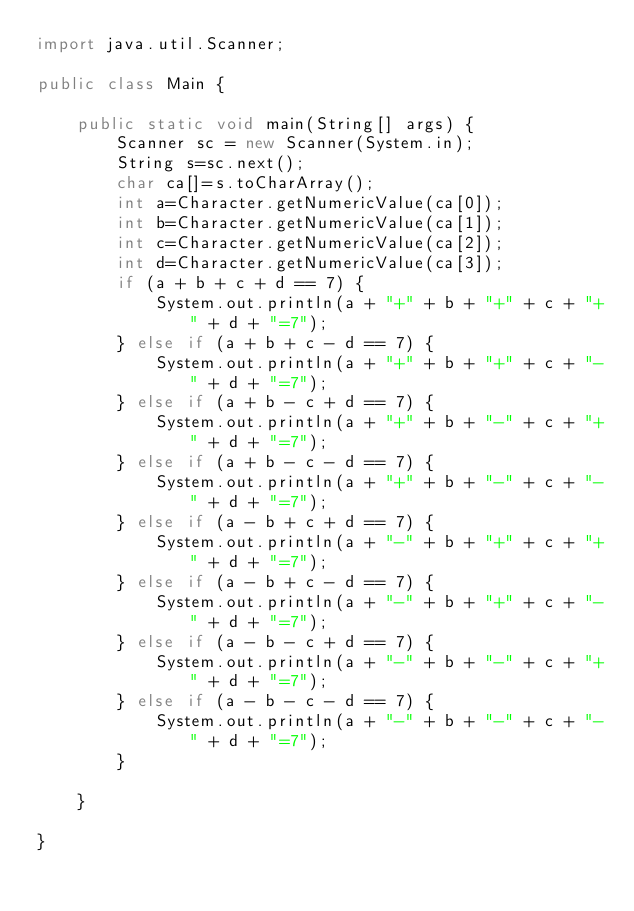<code> <loc_0><loc_0><loc_500><loc_500><_Java_>import java.util.Scanner;

public class Main {

	public static void main(String[] args) {
		Scanner sc = new Scanner(System.in);
		String s=sc.next();
		char ca[]=s.toCharArray();
		int a=Character.getNumericValue(ca[0]);
		int b=Character.getNumericValue(ca[1]);
		int c=Character.getNumericValue(ca[2]);
		int d=Character.getNumericValue(ca[3]);
		if (a + b + c + d == 7) {
			System.out.println(a + "+" + b + "+" + c + "+" + d + "=7");
		} else if (a + b + c - d == 7) {
			System.out.println(a + "+" + b + "+" + c + "-" + d + "=7");
		} else if (a + b - c + d == 7) {
			System.out.println(a + "+" + b + "-" + c + "+" + d + "=7");
		} else if (a + b - c - d == 7) {
			System.out.println(a + "+" + b + "-" + c + "-" + d + "=7");
		} else if (a - b + c + d == 7) {
			System.out.println(a + "-" + b + "+" + c + "+" + d + "=7");
		} else if (a - b + c - d == 7) {
			System.out.println(a + "-" + b + "+" + c + "-" + d + "=7");
		} else if (a - b - c + d == 7) {
			System.out.println(a + "-" + b + "-" + c + "+" + d + "=7");
		} else if (a - b - c - d == 7) {
			System.out.println(a + "-" + b + "-" + c + "-" + d + "=7");
		}

	}

}</code> 